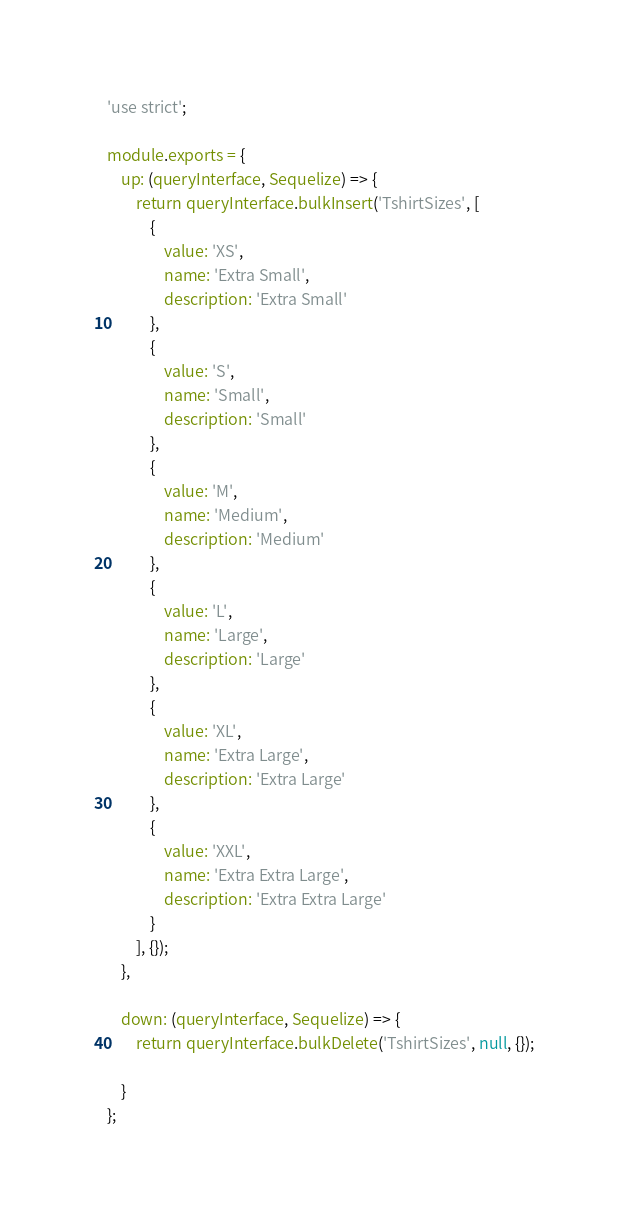Convert code to text. <code><loc_0><loc_0><loc_500><loc_500><_JavaScript_>'use strict';

module.exports = {
    up: (queryInterface, Sequelize) => {
        return queryInterface.bulkInsert('TshirtSizes', [
            {
                value: 'XS',
                name: 'Extra Small',
                description: 'Extra Small'
            },
            {
                value: 'S',
                name: 'Small',
                description: 'Small'
            },
            {
                value: 'M',
                name: 'Medium',
                description: 'Medium'
            },
            {
                value: 'L',
                name: 'Large',
                description: 'Large'
            },
            {
                value: 'XL',
                name: 'Extra Large',
                description: 'Extra Large'
            },
            {
                value: 'XXL',
                name: 'Extra Extra Large',
                description: 'Extra Extra Large'
            }
        ], {});
    },

    down: (queryInterface, Sequelize) => {
        return queryInterface.bulkDelete('TshirtSizes', null, {});

    }
};
</code> 